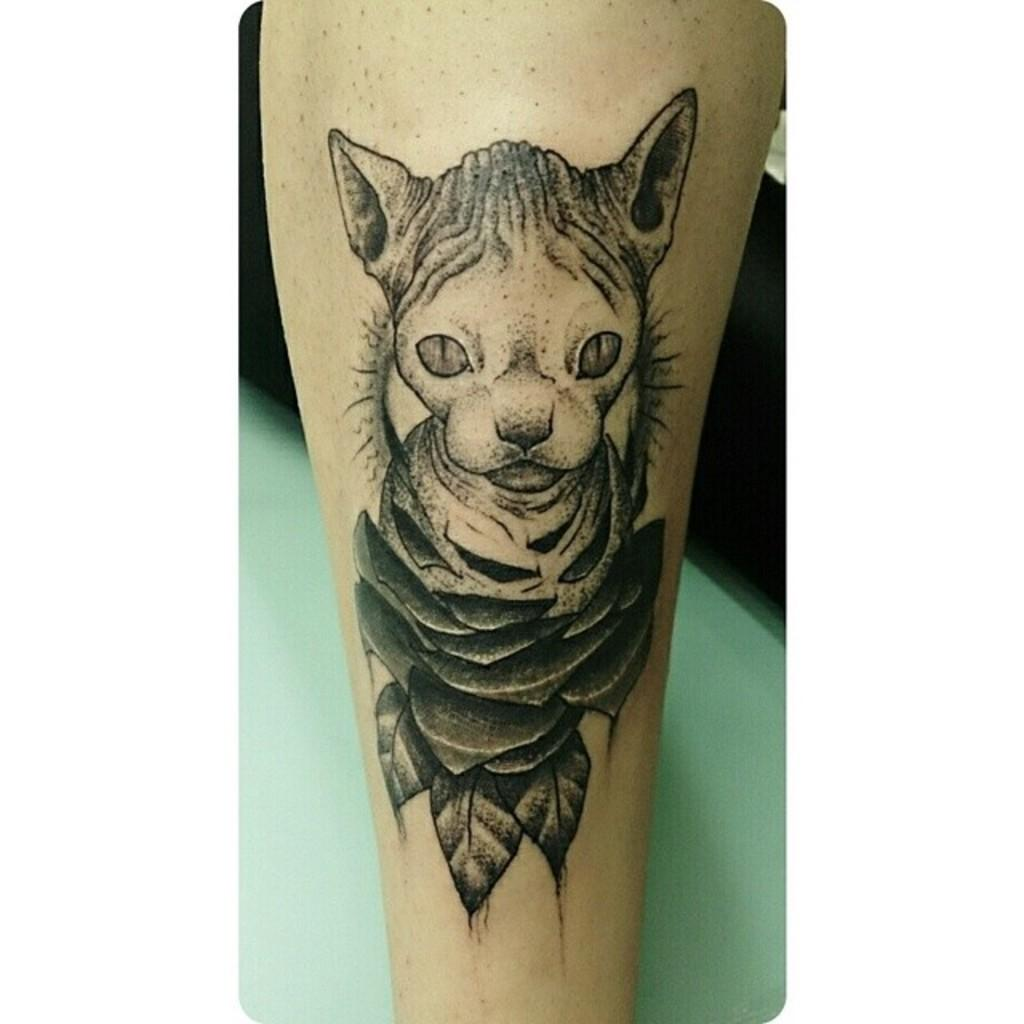What can be seen on a leg in the image? There is a tattoo on a leg in the image. What is visible in the background of the image? There is a platform visible in the background of the image. How many bars of soap are on the platform in the image? There is no soap present in the image; it only features a tattoo on a leg and a platform in the background. 